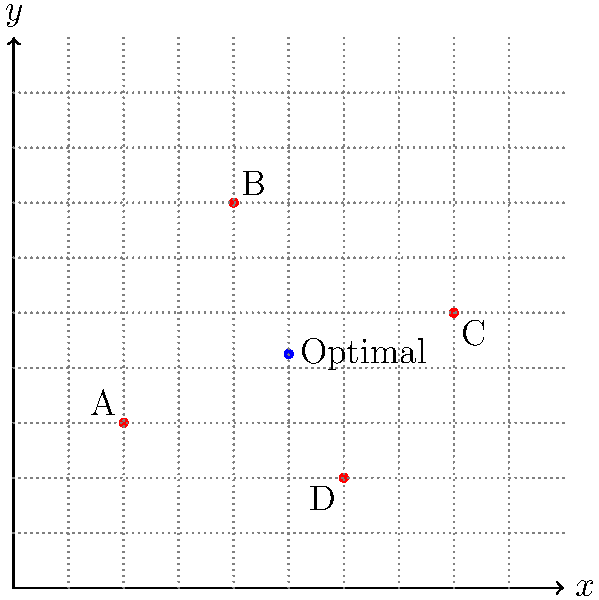For an upcoming product launch, you need to find the optimal venue location based on the coordinates of four key influencers. Their locations are given as follows:

Influencer A: (2, 3)
Influencer B: (4, 7)
Influencer C: (8, 5)
Influencer D: (6, 2)

To minimize travel for all influencers, you decide to choose a location that represents the average of their coordinates. What are the coordinates of the optimal venue location? Round your answer to two decimal places. To find the optimal venue location, we need to calculate the average of the x-coordinates and y-coordinates separately:

1. Calculate the average x-coordinate:
   $x_{avg} = \frac{x_A + x_B + x_C + x_D}{4} = \frac{2 + 4 + 8 + 6}{4} = \frac{20}{4} = 5$

2. Calculate the average y-coordinate:
   $y_{avg} = \frac{y_A + y_B + y_C + y_D}{4} = \frac{3 + 7 + 5 + 2}{4} = \frac{17}{4} = 4.25$

3. The optimal venue location is the point $(x_{avg}, y_{avg}) = (5, 4.25)$

This point represents the centroid of the quadrilateral formed by the four influencer locations, which minimizes the total distance traveled by all influencers.
Answer: (5.00, 4.25) 